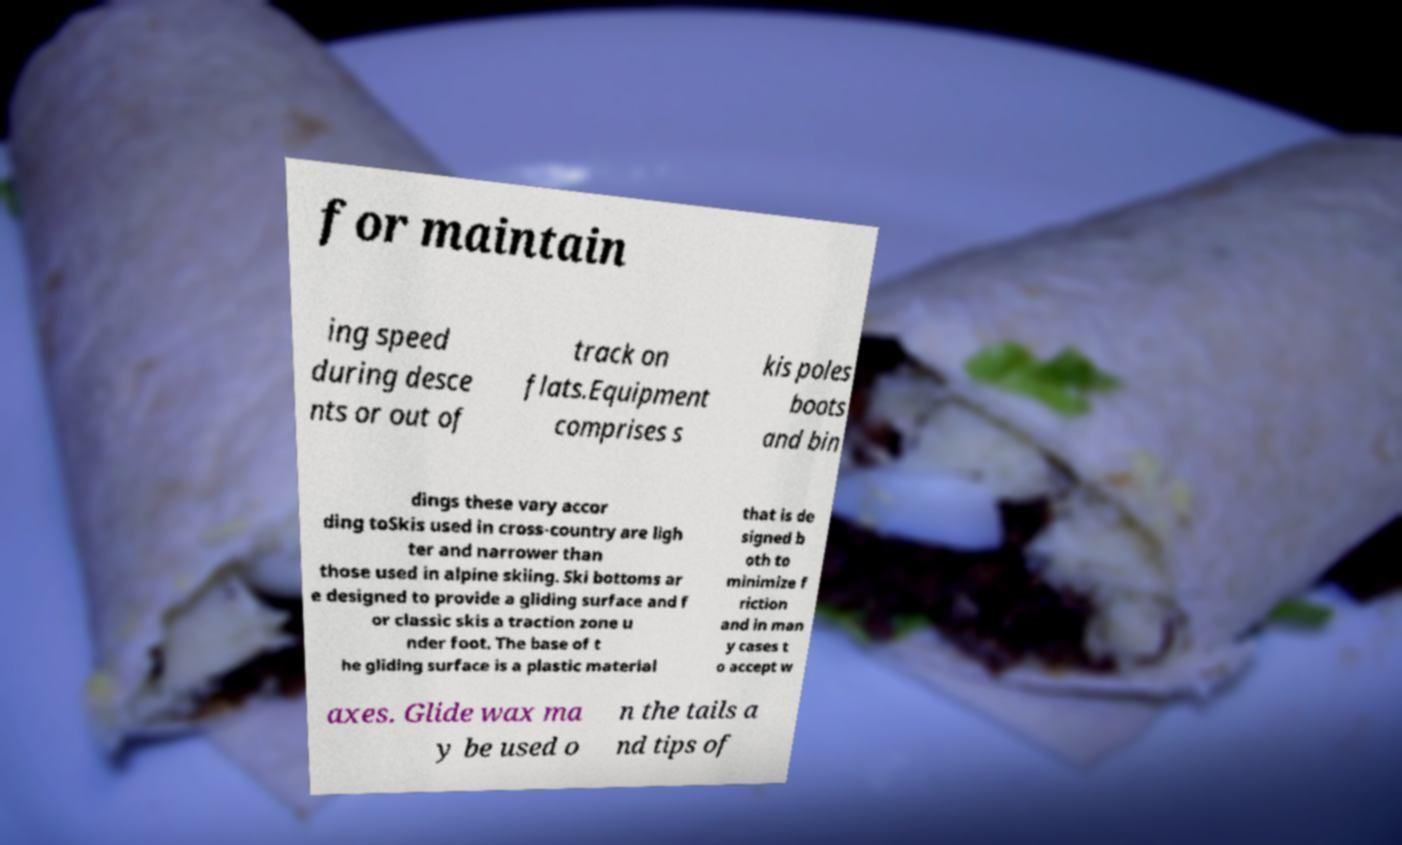I need the written content from this picture converted into text. Can you do that? for maintain ing speed during desce nts or out of track on flats.Equipment comprises s kis poles boots and bin dings these vary accor ding toSkis used in cross-country are ligh ter and narrower than those used in alpine skiing. Ski bottoms ar e designed to provide a gliding surface and f or classic skis a traction zone u nder foot. The base of t he gliding surface is a plastic material that is de signed b oth to minimize f riction and in man y cases t o accept w axes. Glide wax ma y be used o n the tails a nd tips of 